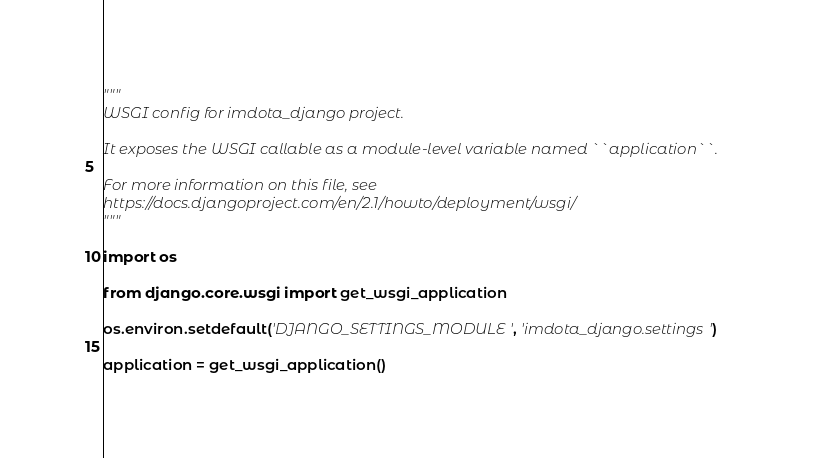<code> <loc_0><loc_0><loc_500><loc_500><_Python_>"""
WSGI config for imdota_django project.

It exposes the WSGI callable as a module-level variable named ``application``.

For more information on this file, see
https://docs.djangoproject.com/en/2.1/howto/deployment/wsgi/
"""

import os

from django.core.wsgi import get_wsgi_application

os.environ.setdefault('DJANGO_SETTINGS_MODULE', 'imdota_django.settings')

application = get_wsgi_application()
</code> 